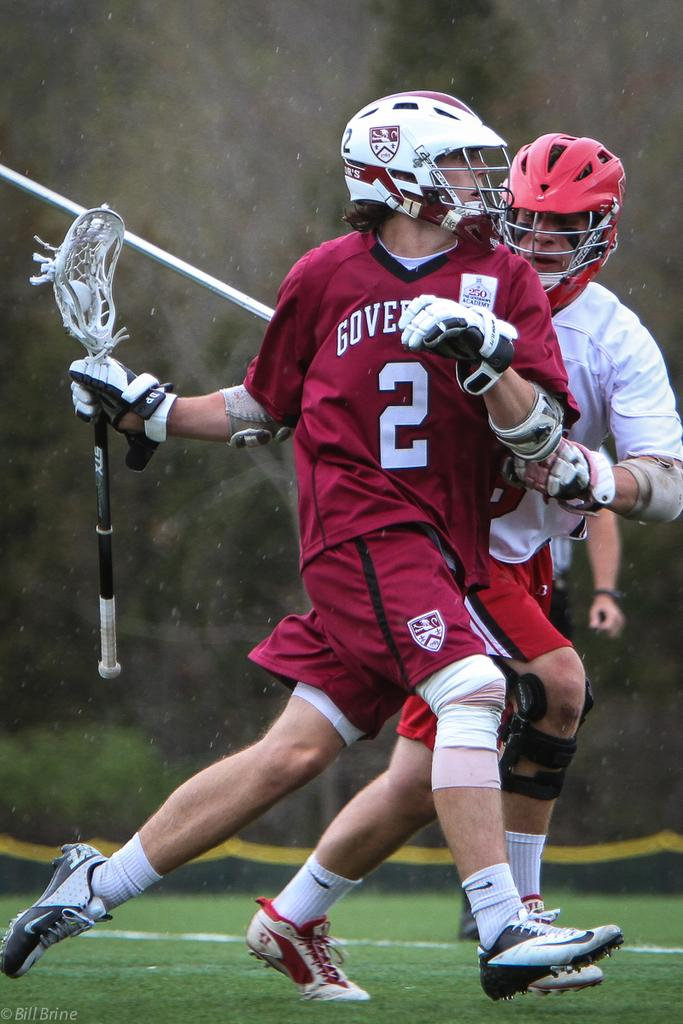<image>
Offer a succinct explanation of the picture presented. the number 2 player that is on a field 